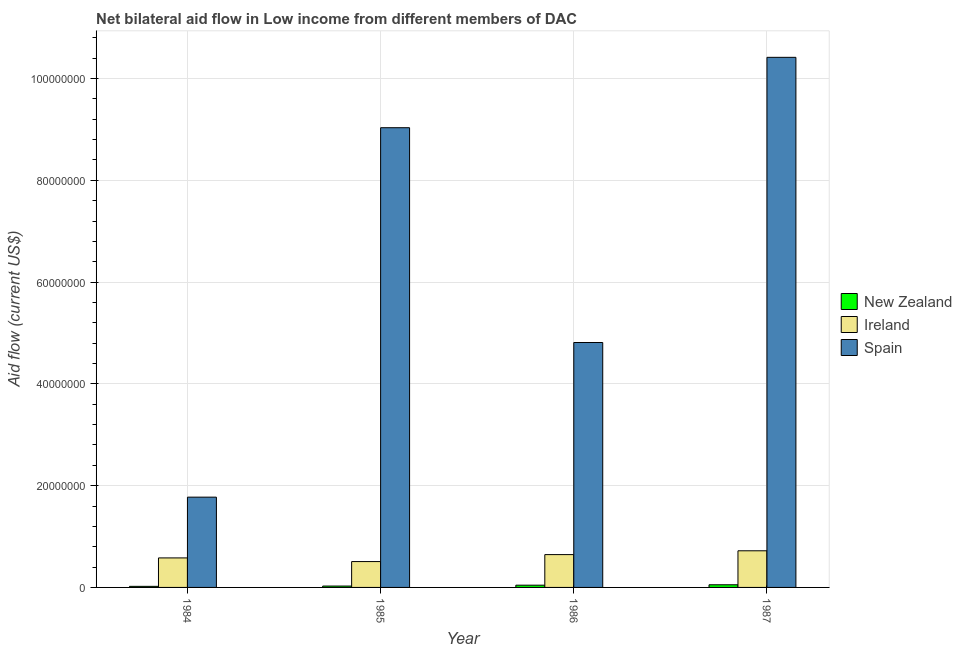How many different coloured bars are there?
Give a very brief answer. 3. How many groups of bars are there?
Make the answer very short. 4. Are the number of bars on each tick of the X-axis equal?
Offer a terse response. Yes. What is the label of the 1st group of bars from the left?
Offer a very short reply. 1984. In how many cases, is the number of bars for a given year not equal to the number of legend labels?
Give a very brief answer. 0. What is the amount of aid provided by spain in 1985?
Ensure brevity in your answer.  9.03e+07. Across all years, what is the maximum amount of aid provided by new zealand?
Provide a short and direct response. 5.20e+05. Across all years, what is the minimum amount of aid provided by ireland?
Provide a short and direct response. 5.08e+06. In which year was the amount of aid provided by new zealand minimum?
Your answer should be very brief. 1984. What is the total amount of aid provided by ireland in the graph?
Your response must be concise. 2.45e+07. What is the difference between the amount of aid provided by ireland in 1984 and that in 1985?
Offer a terse response. 7.20e+05. What is the difference between the amount of aid provided by new zealand in 1985 and the amount of aid provided by spain in 1984?
Give a very brief answer. 6.00e+04. What is the ratio of the amount of aid provided by ireland in 1986 to that in 1987?
Your answer should be very brief. 0.9. Is the amount of aid provided by new zealand in 1984 less than that in 1986?
Your answer should be compact. Yes. What is the difference between the highest and the second highest amount of aid provided by spain?
Your response must be concise. 1.38e+07. What is the difference between the highest and the lowest amount of aid provided by ireland?
Give a very brief answer. 2.12e+06. What does the 2nd bar from the left in 1986 represents?
Provide a short and direct response. Ireland. What does the 2nd bar from the right in 1985 represents?
Keep it short and to the point. Ireland. Is it the case that in every year, the sum of the amount of aid provided by new zealand and amount of aid provided by ireland is greater than the amount of aid provided by spain?
Ensure brevity in your answer.  No. How many years are there in the graph?
Keep it short and to the point. 4. What is the difference between two consecutive major ticks on the Y-axis?
Your answer should be very brief. 2.00e+07. Are the values on the major ticks of Y-axis written in scientific E-notation?
Your answer should be very brief. No. How many legend labels are there?
Your answer should be compact. 3. How are the legend labels stacked?
Your response must be concise. Vertical. What is the title of the graph?
Your response must be concise. Net bilateral aid flow in Low income from different members of DAC. What is the label or title of the X-axis?
Give a very brief answer. Year. What is the label or title of the Y-axis?
Make the answer very short. Aid flow (current US$). What is the Aid flow (current US$) in Ireland in 1984?
Provide a short and direct response. 5.80e+06. What is the Aid flow (current US$) in Spain in 1984?
Make the answer very short. 1.77e+07. What is the Aid flow (current US$) of Ireland in 1985?
Make the answer very short. 5.08e+06. What is the Aid flow (current US$) of Spain in 1985?
Offer a very short reply. 9.03e+07. What is the Aid flow (current US$) in New Zealand in 1986?
Provide a short and direct response. 4.40e+05. What is the Aid flow (current US$) in Ireland in 1986?
Your response must be concise. 6.45e+06. What is the Aid flow (current US$) of Spain in 1986?
Give a very brief answer. 4.81e+07. What is the Aid flow (current US$) of New Zealand in 1987?
Your answer should be compact. 5.20e+05. What is the Aid flow (current US$) in Ireland in 1987?
Provide a short and direct response. 7.20e+06. What is the Aid flow (current US$) of Spain in 1987?
Offer a terse response. 1.04e+08. Across all years, what is the maximum Aid flow (current US$) of New Zealand?
Provide a succinct answer. 5.20e+05. Across all years, what is the maximum Aid flow (current US$) of Ireland?
Your response must be concise. 7.20e+06. Across all years, what is the maximum Aid flow (current US$) in Spain?
Make the answer very short. 1.04e+08. Across all years, what is the minimum Aid flow (current US$) in Ireland?
Provide a succinct answer. 5.08e+06. Across all years, what is the minimum Aid flow (current US$) in Spain?
Your answer should be compact. 1.77e+07. What is the total Aid flow (current US$) of New Zealand in the graph?
Provide a short and direct response. 1.44e+06. What is the total Aid flow (current US$) in Ireland in the graph?
Give a very brief answer. 2.45e+07. What is the total Aid flow (current US$) of Spain in the graph?
Provide a succinct answer. 2.60e+08. What is the difference between the Aid flow (current US$) of Ireland in 1984 and that in 1985?
Offer a terse response. 7.20e+05. What is the difference between the Aid flow (current US$) in Spain in 1984 and that in 1985?
Make the answer very short. -7.26e+07. What is the difference between the Aid flow (current US$) in Ireland in 1984 and that in 1986?
Your response must be concise. -6.50e+05. What is the difference between the Aid flow (current US$) of Spain in 1984 and that in 1986?
Provide a short and direct response. -3.04e+07. What is the difference between the Aid flow (current US$) in New Zealand in 1984 and that in 1987?
Give a very brief answer. -3.10e+05. What is the difference between the Aid flow (current US$) of Ireland in 1984 and that in 1987?
Make the answer very short. -1.40e+06. What is the difference between the Aid flow (current US$) of Spain in 1984 and that in 1987?
Give a very brief answer. -8.64e+07. What is the difference between the Aid flow (current US$) of New Zealand in 1985 and that in 1986?
Your response must be concise. -1.70e+05. What is the difference between the Aid flow (current US$) of Ireland in 1985 and that in 1986?
Keep it short and to the point. -1.37e+06. What is the difference between the Aid flow (current US$) of Spain in 1985 and that in 1986?
Give a very brief answer. 4.22e+07. What is the difference between the Aid flow (current US$) in New Zealand in 1985 and that in 1987?
Keep it short and to the point. -2.50e+05. What is the difference between the Aid flow (current US$) in Ireland in 1985 and that in 1987?
Your response must be concise. -2.12e+06. What is the difference between the Aid flow (current US$) in Spain in 1985 and that in 1987?
Offer a terse response. -1.38e+07. What is the difference between the Aid flow (current US$) in Ireland in 1986 and that in 1987?
Offer a terse response. -7.50e+05. What is the difference between the Aid flow (current US$) of Spain in 1986 and that in 1987?
Offer a terse response. -5.60e+07. What is the difference between the Aid flow (current US$) in New Zealand in 1984 and the Aid flow (current US$) in Ireland in 1985?
Make the answer very short. -4.87e+06. What is the difference between the Aid flow (current US$) of New Zealand in 1984 and the Aid flow (current US$) of Spain in 1985?
Offer a terse response. -9.01e+07. What is the difference between the Aid flow (current US$) in Ireland in 1984 and the Aid flow (current US$) in Spain in 1985?
Provide a short and direct response. -8.45e+07. What is the difference between the Aid flow (current US$) of New Zealand in 1984 and the Aid flow (current US$) of Ireland in 1986?
Keep it short and to the point. -6.24e+06. What is the difference between the Aid flow (current US$) of New Zealand in 1984 and the Aid flow (current US$) of Spain in 1986?
Ensure brevity in your answer.  -4.79e+07. What is the difference between the Aid flow (current US$) of Ireland in 1984 and the Aid flow (current US$) of Spain in 1986?
Make the answer very short. -4.23e+07. What is the difference between the Aid flow (current US$) in New Zealand in 1984 and the Aid flow (current US$) in Ireland in 1987?
Offer a terse response. -6.99e+06. What is the difference between the Aid flow (current US$) in New Zealand in 1984 and the Aid flow (current US$) in Spain in 1987?
Provide a short and direct response. -1.04e+08. What is the difference between the Aid flow (current US$) of Ireland in 1984 and the Aid flow (current US$) of Spain in 1987?
Provide a succinct answer. -9.84e+07. What is the difference between the Aid flow (current US$) in New Zealand in 1985 and the Aid flow (current US$) in Ireland in 1986?
Your answer should be very brief. -6.18e+06. What is the difference between the Aid flow (current US$) in New Zealand in 1985 and the Aid flow (current US$) in Spain in 1986?
Give a very brief answer. -4.79e+07. What is the difference between the Aid flow (current US$) in Ireland in 1985 and the Aid flow (current US$) in Spain in 1986?
Provide a short and direct response. -4.30e+07. What is the difference between the Aid flow (current US$) of New Zealand in 1985 and the Aid flow (current US$) of Ireland in 1987?
Keep it short and to the point. -6.93e+06. What is the difference between the Aid flow (current US$) in New Zealand in 1985 and the Aid flow (current US$) in Spain in 1987?
Make the answer very short. -1.04e+08. What is the difference between the Aid flow (current US$) in Ireland in 1985 and the Aid flow (current US$) in Spain in 1987?
Offer a terse response. -9.91e+07. What is the difference between the Aid flow (current US$) in New Zealand in 1986 and the Aid flow (current US$) in Ireland in 1987?
Provide a succinct answer. -6.76e+06. What is the difference between the Aid flow (current US$) in New Zealand in 1986 and the Aid flow (current US$) in Spain in 1987?
Your answer should be compact. -1.04e+08. What is the difference between the Aid flow (current US$) in Ireland in 1986 and the Aid flow (current US$) in Spain in 1987?
Keep it short and to the point. -9.77e+07. What is the average Aid flow (current US$) in Ireland per year?
Keep it short and to the point. 6.13e+06. What is the average Aid flow (current US$) in Spain per year?
Your answer should be very brief. 6.51e+07. In the year 1984, what is the difference between the Aid flow (current US$) of New Zealand and Aid flow (current US$) of Ireland?
Offer a terse response. -5.59e+06. In the year 1984, what is the difference between the Aid flow (current US$) in New Zealand and Aid flow (current US$) in Spain?
Your answer should be very brief. -1.75e+07. In the year 1984, what is the difference between the Aid flow (current US$) in Ireland and Aid flow (current US$) in Spain?
Provide a succinct answer. -1.19e+07. In the year 1985, what is the difference between the Aid flow (current US$) in New Zealand and Aid flow (current US$) in Ireland?
Offer a very short reply. -4.81e+06. In the year 1985, what is the difference between the Aid flow (current US$) in New Zealand and Aid flow (current US$) in Spain?
Your answer should be compact. -9.01e+07. In the year 1985, what is the difference between the Aid flow (current US$) in Ireland and Aid flow (current US$) in Spain?
Offer a very short reply. -8.53e+07. In the year 1986, what is the difference between the Aid flow (current US$) in New Zealand and Aid flow (current US$) in Ireland?
Your response must be concise. -6.01e+06. In the year 1986, what is the difference between the Aid flow (current US$) of New Zealand and Aid flow (current US$) of Spain?
Your response must be concise. -4.77e+07. In the year 1986, what is the difference between the Aid flow (current US$) of Ireland and Aid flow (current US$) of Spain?
Your answer should be compact. -4.17e+07. In the year 1987, what is the difference between the Aid flow (current US$) in New Zealand and Aid flow (current US$) in Ireland?
Offer a very short reply. -6.68e+06. In the year 1987, what is the difference between the Aid flow (current US$) in New Zealand and Aid flow (current US$) in Spain?
Your answer should be very brief. -1.04e+08. In the year 1987, what is the difference between the Aid flow (current US$) in Ireland and Aid flow (current US$) in Spain?
Your response must be concise. -9.70e+07. What is the ratio of the Aid flow (current US$) of New Zealand in 1984 to that in 1985?
Keep it short and to the point. 0.78. What is the ratio of the Aid flow (current US$) in Ireland in 1984 to that in 1985?
Ensure brevity in your answer.  1.14. What is the ratio of the Aid flow (current US$) of Spain in 1984 to that in 1985?
Your response must be concise. 0.2. What is the ratio of the Aid flow (current US$) in New Zealand in 1984 to that in 1986?
Provide a short and direct response. 0.48. What is the ratio of the Aid flow (current US$) of Ireland in 1984 to that in 1986?
Provide a succinct answer. 0.9. What is the ratio of the Aid flow (current US$) of Spain in 1984 to that in 1986?
Offer a very short reply. 0.37. What is the ratio of the Aid flow (current US$) in New Zealand in 1984 to that in 1987?
Ensure brevity in your answer.  0.4. What is the ratio of the Aid flow (current US$) of Ireland in 1984 to that in 1987?
Your response must be concise. 0.81. What is the ratio of the Aid flow (current US$) in Spain in 1984 to that in 1987?
Keep it short and to the point. 0.17. What is the ratio of the Aid flow (current US$) of New Zealand in 1985 to that in 1986?
Ensure brevity in your answer.  0.61. What is the ratio of the Aid flow (current US$) in Ireland in 1985 to that in 1986?
Provide a succinct answer. 0.79. What is the ratio of the Aid flow (current US$) in Spain in 1985 to that in 1986?
Offer a terse response. 1.88. What is the ratio of the Aid flow (current US$) of New Zealand in 1985 to that in 1987?
Offer a very short reply. 0.52. What is the ratio of the Aid flow (current US$) in Ireland in 1985 to that in 1987?
Your answer should be compact. 0.71. What is the ratio of the Aid flow (current US$) in Spain in 1985 to that in 1987?
Your answer should be compact. 0.87. What is the ratio of the Aid flow (current US$) of New Zealand in 1986 to that in 1987?
Your answer should be compact. 0.85. What is the ratio of the Aid flow (current US$) of Ireland in 1986 to that in 1987?
Provide a succinct answer. 0.9. What is the ratio of the Aid flow (current US$) of Spain in 1986 to that in 1987?
Give a very brief answer. 0.46. What is the difference between the highest and the second highest Aid flow (current US$) in New Zealand?
Your response must be concise. 8.00e+04. What is the difference between the highest and the second highest Aid flow (current US$) of Ireland?
Make the answer very short. 7.50e+05. What is the difference between the highest and the second highest Aid flow (current US$) of Spain?
Offer a very short reply. 1.38e+07. What is the difference between the highest and the lowest Aid flow (current US$) in Ireland?
Make the answer very short. 2.12e+06. What is the difference between the highest and the lowest Aid flow (current US$) in Spain?
Keep it short and to the point. 8.64e+07. 